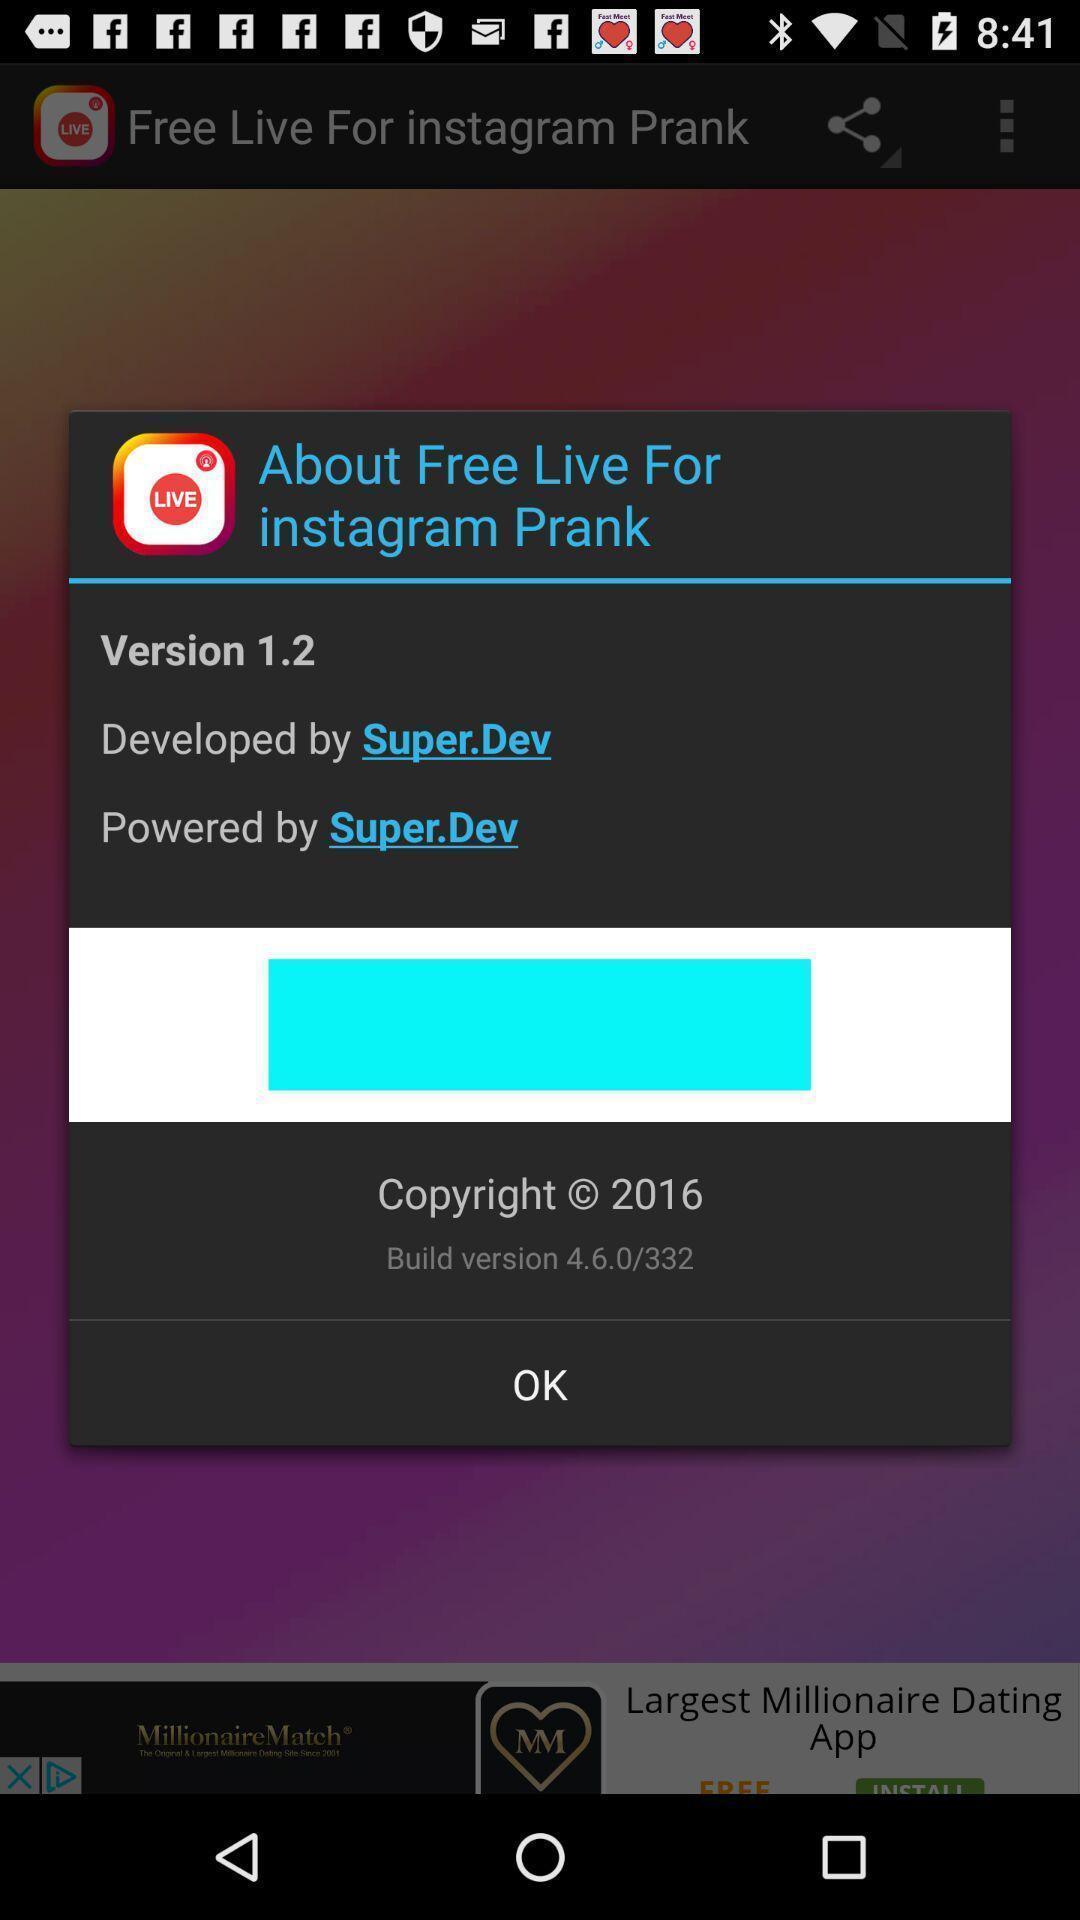Give me a summary of this screen capture. Pop-up displaying information about an application. 